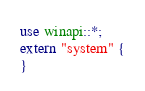Convert code to text. <code><loc_0><loc_0><loc_500><loc_500><_Rust_>use winapi::*;
extern "system" {
}
</code> 